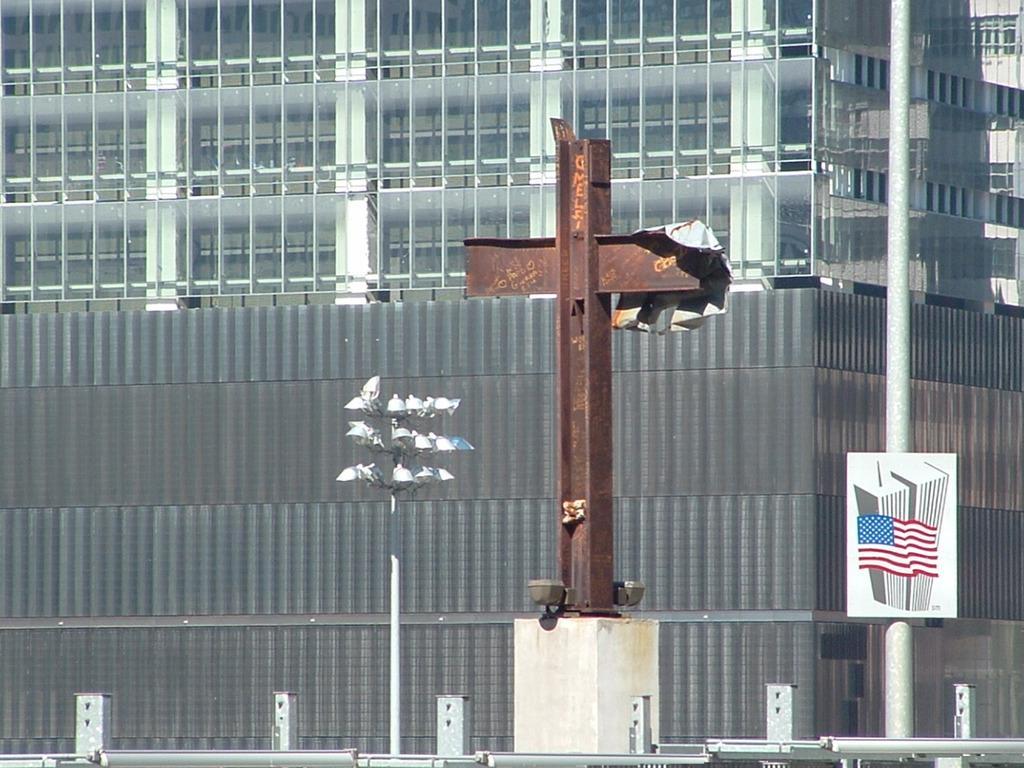Can you describe this image briefly? In this picture we can observe a cross. On the right side there is a pole to which a white color board was fixed to it. We can observe a pole here. In the background there is a large building. 